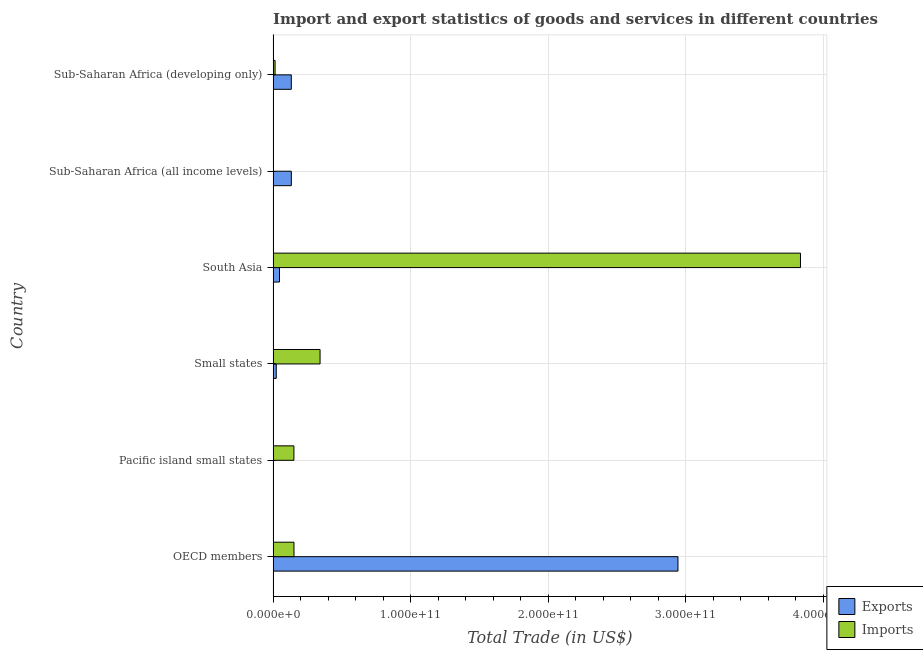How many different coloured bars are there?
Give a very brief answer. 2. How many groups of bars are there?
Keep it short and to the point. 6. Are the number of bars per tick equal to the number of legend labels?
Offer a terse response. Yes. Are the number of bars on each tick of the Y-axis equal?
Offer a very short reply. Yes. How many bars are there on the 1st tick from the top?
Your answer should be very brief. 2. How many bars are there on the 2nd tick from the bottom?
Provide a succinct answer. 2. What is the label of the 3rd group of bars from the top?
Give a very brief answer. South Asia. In how many cases, is the number of bars for a given country not equal to the number of legend labels?
Offer a terse response. 0. What is the imports of goods and services in Sub-Saharan Africa (all income levels)?
Ensure brevity in your answer.  2.09e+08. Across all countries, what is the maximum imports of goods and services?
Your response must be concise. 3.84e+11. Across all countries, what is the minimum export of goods and services?
Ensure brevity in your answer.  1.53e+08. In which country was the imports of goods and services minimum?
Your answer should be compact. Sub-Saharan Africa (all income levels). What is the total export of goods and services in the graph?
Make the answer very short. 3.28e+11. What is the difference between the export of goods and services in OECD members and that in Small states?
Your answer should be very brief. 2.92e+11. What is the difference between the imports of goods and services in Small states and the export of goods and services in Sub-Saharan Africa (developing only)?
Your response must be concise. 2.09e+1. What is the average export of goods and services per country?
Your answer should be compact. 5.47e+1. What is the difference between the export of goods and services and imports of goods and services in South Asia?
Your answer should be very brief. -3.79e+11. In how many countries, is the imports of goods and services greater than 220000000000 US$?
Offer a very short reply. 1. Is the export of goods and services in OECD members less than that in Sub-Saharan Africa (all income levels)?
Provide a succinct answer. No. Is the difference between the imports of goods and services in Sub-Saharan Africa (all income levels) and Sub-Saharan Africa (developing only) greater than the difference between the export of goods and services in Sub-Saharan Africa (all income levels) and Sub-Saharan Africa (developing only)?
Your answer should be very brief. No. What is the difference between the highest and the second highest export of goods and services?
Ensure brevity in your answer.  2.81e+11. What is the difference between the highest and the lowest imports of goods and services?
Your answer should be compact. 3.83e+11. In how many countries, is the imports of goods and services greater than the average imports of goods and services taken over all countries?
Your response must be concise. 1. Is the sum of the export of goods and services in South Asia and Sub-Saharan Africa (developing only) greater than the maximum imports of goods and services across all countries?
Your answer should be very brief. No. What does the 2nd bar from the top in South Asia represents?
Provide a succinct answer. Exports. What does the 1st bar from the bottom in Pacific island small states represents?
Keep it short and to the point. Exports. How many bars are there?
Your answer should be compact. 12. Are all the bars in the graph horizontal?
Offer a very short reply. Yes. How many countries are there in the graph?
Ensure brevity in your answer.  6. What is the difference between two consecutive major ticks on the X-axis?
Your response must be concise. 1.00e+11. Are the values on the major ticks of X-axis written in scientific E-notation?
Your answer should be very brief. Yes. Does the graph contain any zero values?
Your answer should be very brief. No. Does the graph contain grids?
Offer a terse response. Yes. What is the title of the graph?
Provide a succinct answer. Import and export statistics of goods and services in different countries. Does "Resident" appear as one of the legend labels in the graph?
Your answer should be very brief. No. What is the label or title of the X-axis?
Offer a very short reply. Total Trade (in US$). What is the Total Trade (in US$) in Exports in OECD members?
Keep it short and to the point. 2.94e+11. What is the Total Trade (in US$) of Imports in OECD members?
Offer a terse response. 1.52e+1. What is the Total Trade (in US$) in Exports in Pacific island small states?
Your response must be concise. 1.53e+08. What is the Total Trade (in US$) in Imports in Pacific island small states?
Offer a very short reply. 1.51e+1. What is the Total Trade (in US$) of Exports in Small states?
Offer a terse response. 2.27e+09. What is the Total Trade (in US$) in Imports in Small states?
Provide a succinct answer. 3.41e+1. What is the Total Trade (in US$) of Exports in South Asia?
Provide a short and direct response. 4.64e+09. What is the Total Trade (in US$) in Imports in South Asia?
Ensure brevity in your answer.  3.84e+11. What is the Total Trade (in US$) of Exports in Sub-Saharan Africa (all income levels)?
Keep it short and to the point. 1.32e+1. What is the Total Trade (in US$) of Imports in Sub-Saharan Africa (all income levels)?
Offer a very short reply. 2.09e+08. What is the Total Trade (in US$) of Exports in Sub-Saharan Africa (developing only)?
Make the answer very short. 1.32e+1. What is the Total Trade (in US$) in Imports in Sub-Saharan Africa (developing only)?
Your answer should be very brief. 1.42e+09. Across all countries, what is the maximum Total Trade (in US$) in Exports?
Make the answer very short. 2.94e+11. Across all countries, what is the maximum Total Trade (in US$) in Imports?
Ensure brevity in your answer.  3.84e+11. Across all countries, what is the minimum Total Trade (in US$) of Exports?
Give a very brief answer. 1.53e+08. Across all countries, what is the minimum Total Trade (in US$) of Imports?
Offer a terse response. 2.09e+08. What is the total Total Trade (in US$) in Exports in the graph?
Provide a short and direct response. 3.28e+11. What is the total Total Trade (in US$) in Imports in the graph?
Give a very brief answer. 4.50e+11. What is the difference between the Total Trade (in US$) in Exports in OECD members and that in Pacific island small states?
Provide a succinct answer. 2.94e+11. What is the difference between the Total Trade (in US$) of Imports in OECD members and that in Pacific island small states?
Provide a short and direct response. 4.05e+07. What is the difference between the Total Trade (in US$) of Exports in OECD members and that in Small states?
Give a very brief answer. 2.92e+11. What is the difference between the Total Trade (in US$) in Imports in OECD members and that in Small states?
Provide a short and direct response. -1.90e+1. What is the difference between the Total Trade (in US$) of Exports in OECD members and that in South Asia?
Your answer should be very brief. 2.90e+11. What is the difference between the Total Trade (in US$) in Imports in OECD members and that in South Asia?
Offer a very short reply. -3.68e+11. What is the difference between the Total Trade (in US$) in Exports in OECD members and that in Sub-Saharan Africa (all income levels)?
Provide a succinct answer. 2.81e+11. What is the difference between the Total Trade (in US$) of Imports in OECD members and that in Sub-Saharan Africa (all income levels)?
Make the answer very short. 1.50e+1. What is the difference between the Total Trade (in US$) of Exports in OECD members and that in Sub-Saharan Africa (developing only)?
Provide a short and direct response. 2.81e+11. What is the difference between the Total Trade (in US$) of Imports in OECD members and that in Sub-Saharan Africa (developing only)?
Give a very brief answer. 1.38e+1. What is the difference between the Total Trade (in US$) in Exports in Pacific island small states and that in Small states?
Your answer should be compact. -2.12e+09. What is the difference between the Total Trade (in US$) of Imports in Pacific island small states and that in Small states?
Make the answer very short. -1.90e+1. What is the difference between the Total Trade (in US$) in Exports in Pacific island small states and that in South Asia?
Offer a very short reply. -4.48e+09. What is the difference between the Total Trade (in US$) in Imports in Pacific island small states and that in South Asia?
Keep it short and to the point. -3.68e+11. What is the difference between the Total Trade (in US$) in Exports in Pacific island small states and that in Sub-Saharan Africa (all income levels)?
Keep it short and to the point. -1.31e+1. What is the difference between the Total Trade (in US$) in Imports in Pacific island small states and that in Sub-Saharan Africa (all income levels)?
Your response must be concise. 1.49e+1. What is the difference between the Total Trade (in US$) of Exports in Pacific island small states and that in Sub-Saharan Africa (developing only)?
Offer a terse response. -1.31e+1. What is the difference between the Total Trade (in US$) of Imports in Pacific island small states and that in Sub-Saharan Africa (developing only)?
Offer a very short reply. 1.37e+1. What is the difference between the Total Trade (in US$) of Exports in Small states and that in South Asia?
Provide a succinct answer. -2.36e+09. What is the difference between the Total Trade (in US$) in Imports in Small states and that in South Asia?
Keep it short and to the point. -3.49e+11. What is the difference between the Total Trade (in US$) in Exports in Small states and that in Sub-Saharan Africa (all income levels)?
Your answer should be compact. -1.10e+1. What is the difference between the Total Trade (in US$) of Imports in Small states and that in Sub-Saharan Africa (all income levels)?
Provide a succinct answer. 3.39e+1. What is the difference between the Total Trade (in US$) of Exports in Small states and that in Sub-Saharan Africa (developing only)?
Give a very brief answer. -1.10e+1. What is the difference between the Total Trade (in US$) of Imports in Small states and that in Sub-Saharan Africa (developing only)?
Your answer should be very brief. 3.27e+1. What is the difference between the Total Trade (in US$) of Exports in South Asia and that in Sub-Saharan Africa (all income levels)?
Provide a succinct answer. -8.61e+09. What is the difference between the Total Trade (in US$) of Imports in South Asia and that in Sub-Saharan Africa (all income levels)?
Offer a very short reply. 3.83e+11. What is the difference between the Total Trade (in US$) in Exports in South Asia and that in Sub-Saharan Africa (developing only)?
Offer a terse response. -8.60e+09. What is the difference between the Total Trade (in US$) of Imports in South Asia and that in Sub-Saharan Africa (developing only)?
Make the answer very short. 3.82e+11. What is the difference between the Total Trade (in US$) in Exports in Sub-Saharan Africa (all income levels) and that in Sub-Saharan Africa (developing only)?
Offer a very short reply. 1.17e+07. What is the difference between the Total Trade (in US$) of Imports in Sub-Saharan Africa (all income levels) and that in Sub-Saharan Africa (developing only)?
Provide a succinct answer. -1.21e+09. What is the difference between the Total Trade (in US$) of Exports in OECD members and the Total Trade (in US$) of Imports in Pacific island small states?
Your response must be concise. 2.79e+11. What is the difference between the Total Trade (in US$) in Exports in OECD members and the Total Trade (in US$) in Imports in Small states?
Your response must be concise. 2.60e+11. What is the difference between the Total Trade (in US$) of Exports in OECD members and the Total Trade (in US$) of Imports in South Asia?
Offer a terse response. -8.91e+1. What is the difference between the Total Trade (in US$) of Exports in OECD members and the Total Trade (in US$) of Imports in Sub-Saharan Africa (all income levels)?
Your answer should be very brief. 2.94e+11. What is the difference between the Total Trade (in US$) of Exports in OECD members and the Total Trade (in US$) of Imports in Sub-Saharan Africa (developing only)?
Provide a succinct answer. 2.93e+11. What is the difference between the Total Trade (in US$) of Exports in Pacific island small states and the Total Trade (in US$) of Imports in Small states?
Provide a short and direct response. -3.40e+1. What is the difference between the Total Trade (in US$) in Exports in Pacific island small states and the Total Trade (in US$) in Imports in South Asia?
Your response must be concise. -3.83e+11. What is the difference between the Total Trade (in US$) of Exports in Pacific island small states and the Total Trade (in US$) of Imports in Sub-Saharan Africa (all income levels)?
Make the answer very short. -5.61e+07. What is the difference between the Total Trade (in US$) of Exports in Pacific island small states and the Total Trade (in US$) of Imports in Sub-Saharan Africa (developing only)?
Your response must be concise. -1.27e+09. What is the difference between the Total Trade (in US$) of Exports in Small states and the Total Trade (in US$) of Imports in South Asia?
Ensure brevity in your answer.  -3.81e+11. What is the difference between the Total Trade (in US$) of Exports in Small states and the Total Trade (in US$) of Imports in Sub-Saharan Africa (all income levels)?
Give a very brief answer. 2.07e+09. What is the difference between the Total Trade (in US$) in Exports in Small states and the Total Trade (in US$) in Imports in Sub-Saharan Africa (developing only)?
Provide a succinct answer. 8.57e+08. What is the difference between the Total Trade (in US$) of Exports in South Asia and the Total Trade (in US$) of Imports in Sub-Saharan Africa (all income levels)?
Provide a succinct answer. 4.43e+09. What is the difference between the Total Trade (in US$) in Exports in South Asia and the Total Trade (in US$) in Imports in Sub-Saharan Africa (developing only)?
Your answer should be very brief. 3.22e+09. What is the difference between the Total Trade (in US$) of Exports in Sub-Saharan Africa (all income levels) and the Total Trade (in US$) of Imports in Sub-Saharan Africa (developing only)?
Your answer should be compact. 1.18e+1. What is the average Total Trade (in US$) of Exports per country?
Provide a short and direct response. 5.47e+1. What is the average Total Trade (in US$) in Imports per country?
Your response must be concise. 7.49e+1. What is the difference between the Total Trade (in US$) in Exports and Total Trade (in US$) in Imports in OECD members?
Your response must be concise. 2.79e+11. What is the difference between the Total Trade (in US$) of Exports and Total Trade (in US$) of Imports in Pacific island small states?
Keep it short and to the point. -1.50e+1. What is the difference between the Total Trade (in US$) of Exports and Total Trade (in US$) of Imports in Small states?
Your answer should be very brief. -3.19e+1. What is the difference between the Total Trade (in US$) in Exports and Total Trade (in US$) in Imports in South Asia?
Your answer should be very brief. -3.79e+11. What is the difference between the Total Trade (in US$) of Exports and Total Trade (in US$) of Imports in Sub-Saharan Africa (all income levels)?
Your answer should be very brief. 1.30e+1. What is the difference between the Total Trade (in US$) in Exports and Total Trade (in US$) in Imports in Sub-Saharan Africa (developing only)?
Ensure brevity in your answer.  1.18e+1. What is the ratio of the Total Trade (in US$) of Exports in OECD members to that in Pacific island small states?
Ensure brevity in your answer.  1927.78. What is the ratio of the Total Trade (in US$) in Imports in OECD members to that in Pacific island small states?
Offer a terse response. 1. What is the ratio of the Total Trade (in US$) in Exports in OECD members to that in Small states?
Provide a short and direct response. 129.44. What is the ratio of the Total Trade (in US$) in Imports in OECD members to that in Small states?
Ensure brevity in your answer.  0.44. What is the ratio of the Total Trade (in US$) of Exports in OECD members to that in South Asia?
Provide a succinct answer. 63.51. What is the ratio of the Total Trade (in US$) of Imports in OECD members to that in South Asia?
Your answer should be compact. 0.04. What is the ratio of the Total Trade (in US$) of Exports in OECD members to that in Sub-Saharan Africa (all income levels)?
Give a very brief answer. 22.23. What is the ratio of the Total Trade (in US$) of Imports in OECD members to that in Sub-Saharan Africa (all income levels)?
Provide a short and direct response. 72.64. What is the ratio of the Total Trade (in US$) in Exports in OECD members to that in Sub-Saharan Africa (developing only)?
Your answer should be compact. 22.25. What is the ratio of the Total Trade (in US$) in Imports in OECD members to that in Sub-Saharan Africa (developing only)?
Make the answer very short. 10.7. What is the ratio of the Total Trade (in US$) in Exports in Pacific island small states to that in Small states?
Keep it short and to the point. 0.07. What is the ratio of the Total Trade (in US$) of Imports in Pacific island small states to that in Small states?
Your answer should be compact. 0.44. What is the ratio of the Total Trade (in US$) in Exports in Pacific island small states to that in South Asia?
Keep it short and to the point. 0.03. What is the ratio of the Total Trade (in US$) in Imports in Pacific island small states to that in South Asia?
Provide a succinct answer. 0.04. What is the ratio of the Total Trade (in US$) in Exports in Pacific island small states to that in Sub-Saharan Africa (all income levels)?
Offer a very short reply. 0.01. What is the ratio of the Total Trade (in US$) in Imports in Pacific island small states to that in Sub-Saharan Africa (all income levels)?
Keep it short and to the point. 72.44. What is the ratio of the Total Trade (in US$) in Exports in Pacific island small states to that in Sub-Saharan Africa (developing only)?
Ensure brevity in your answer.  0.01. What is the ratio of the Total Trade (in US$) in Imports in Pacific island small states to that in Sub-Saharan Africa (developing only)?
Your answer should be compact. 10.67. What is the ratio of the Total Trade (in US$) of Exports in Small states to that in South Asia?
Keep it short and to the point. 0.49. What is the ratio of the Total Trade (in US$) of Imports in Small states to that in South Asia?
Offer a very short reply. 0.09. What is the ratio of the Total Trade (in US$) of Exports in Small states to that in Sub-Saharan Africa (all income levels)?
Your response must be concise. 0.17. What is the ratio of the Total Trade (in US$) of Imports in Small states to that in Sub-Saharan Africa (all income levels)?
Your response must be concise. 163.42. What is the ratio of the Total Trade (in US$) of Exports in Small states to that in Sub-Saharan Africa (developing only)?
Your response must be concise. 0.17. What is the ratio of the Total Trade (in US$) in Imports in Small states to that in Sub-Saharan Africa (developing only)?
Provide a short and direct response. 24.08. What is the ratio of the Total Trade (in US$) of Exports in South Asia to that in Sub-Saharan Africa (all income levels)?
Your answer should be compact. 0.35. What is the ratio of the Total Trade (in US$) of Imports in South Asia to that in Sub-Saharan Africa (all income levels)?
Give a very brief answer. 1836.19. What is the ratio of the Total Trade (in US$) of Exports in South Asia to that in Sub-Saharan Africa (developing only)?
Provide a succinct answer. 0.35. What is the ratio of the Total Trade (in US$) in Imports in South Asia to that in Sub-Saharan Africa (developing only)?
Your answer should be compact. 270.52. What is the ratio of the Total Trade (in US$) of Imports in Sub-Saharan Africa (all income levels) to that in Sub-Saharan Africa (developing only)?
Your answer should be compact. 0.15. What is the difference between the highest and the second highest Total Trade (in US$) in Exports?
Provide a short and direct response. 2.81e+11. What is the difference between the highest and the second highest Total Trade (in US$) of Imports?
Give a very brief answer. 3.49e+11. What is the difference between the highest and the lowest Total Trade (in US$) in Exports?
Provide a short and direct response. 2.94e+11. What is the difference between the highest and the lowest Total Trade (in US$) in Imports?
Ensure brevity in your answer.  3.83e+11. 